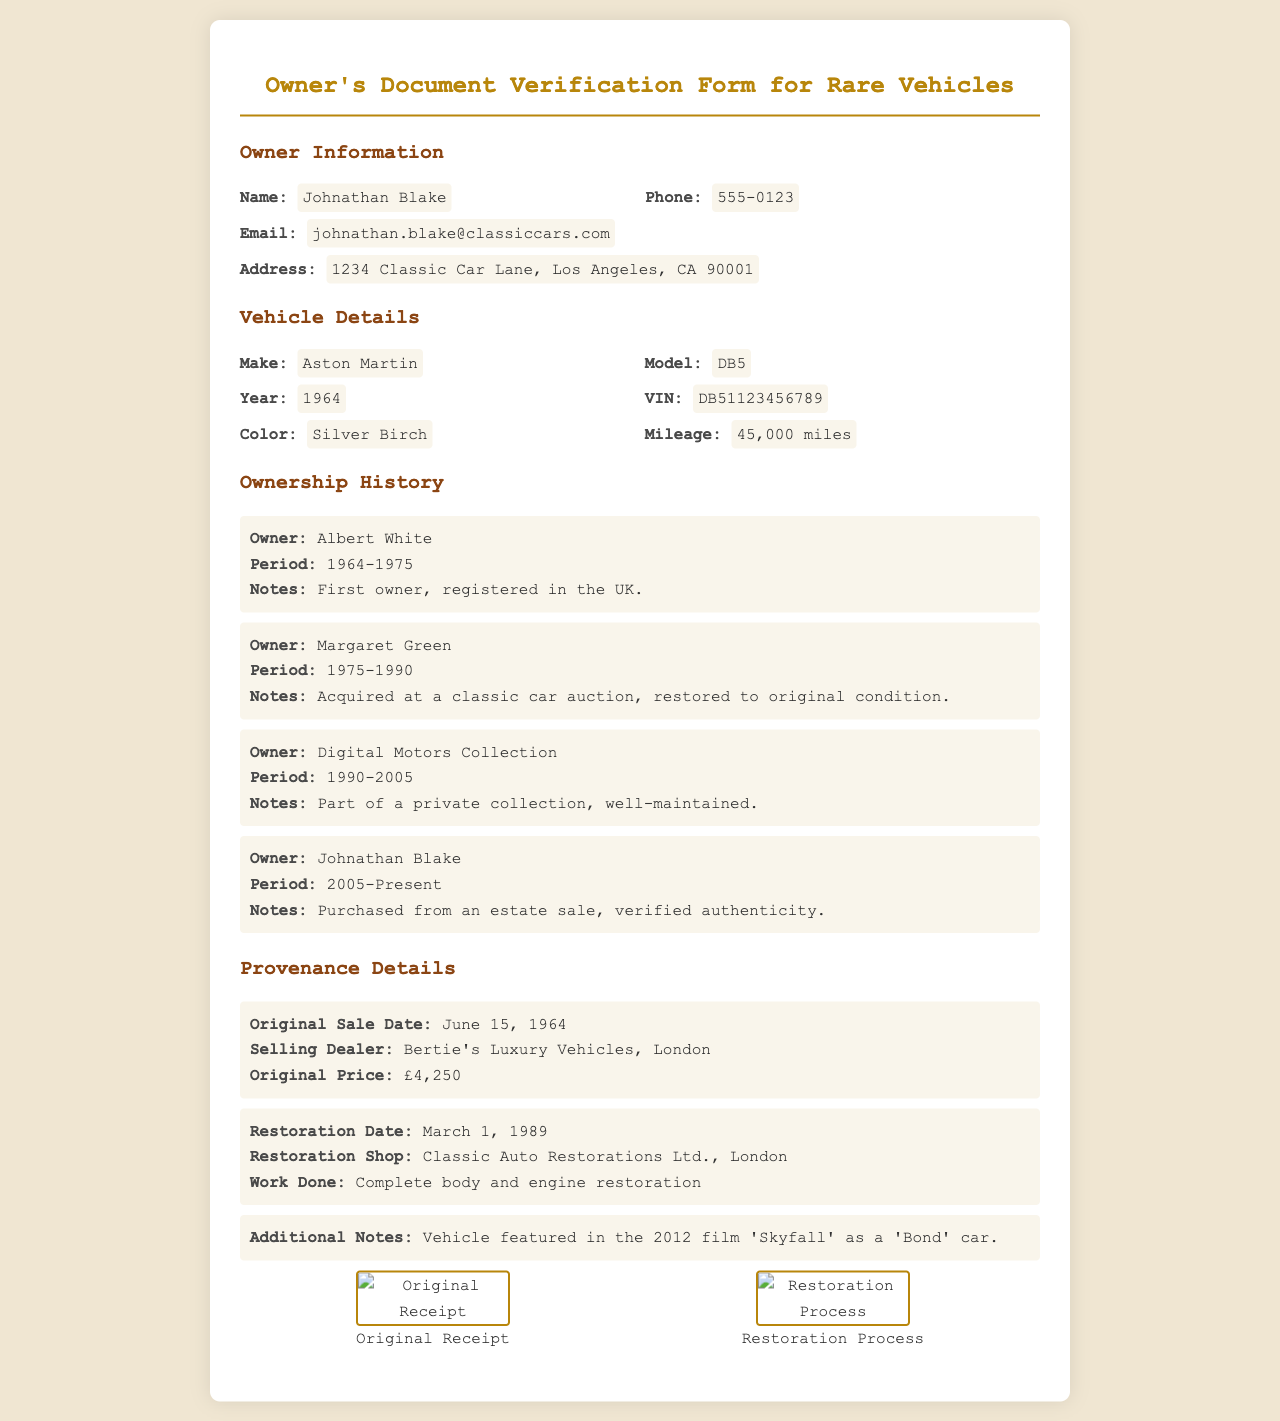what is the name of the owner? The name of the owner is provided under Owner Information at the top of the document.
Answer: Johnathan Blake what is the phone number listed? The phone number can be found in the Owner Information section, clearly marked as the owner's contact number.
Answer: 555-0123 which vehicle make is detailed in the document? The vehicle make can be found in the Vehicle Details section, where it specifies the brand of the car.
Answer: Aston Martin what year was the vehicle manufactured? The year of manufacture is listed in the Vehicle Details section and denotes when the vehicle was produced.
Answer: 1964 who was the first owner of the vehicle? The Ownership History section provides a chronological list of previous owners, starting with the first one.
Answer: Albert White what was the period of ownership by Margaret Green? This information is also found in the Ownership History and details the time frame she owned the vehicle.
Answer: 1975-1990 when was the vehicle originally sold? The Original Sale Date is included in the Provenance Details section, giving the specific date it was first sold.
Answer: June 15, 1964 what type of restoration work was done on the vehicle in 1989? The type of restoration work can be found in the Provenance Details, specifically outlining what was accomplished during that time.
Answer: Complete body and engine restoration what notable film featured the vehicle? The Additional Notes in the Provenance Details mention the film in which the vehicle was featured.
Answer: Skyfall 